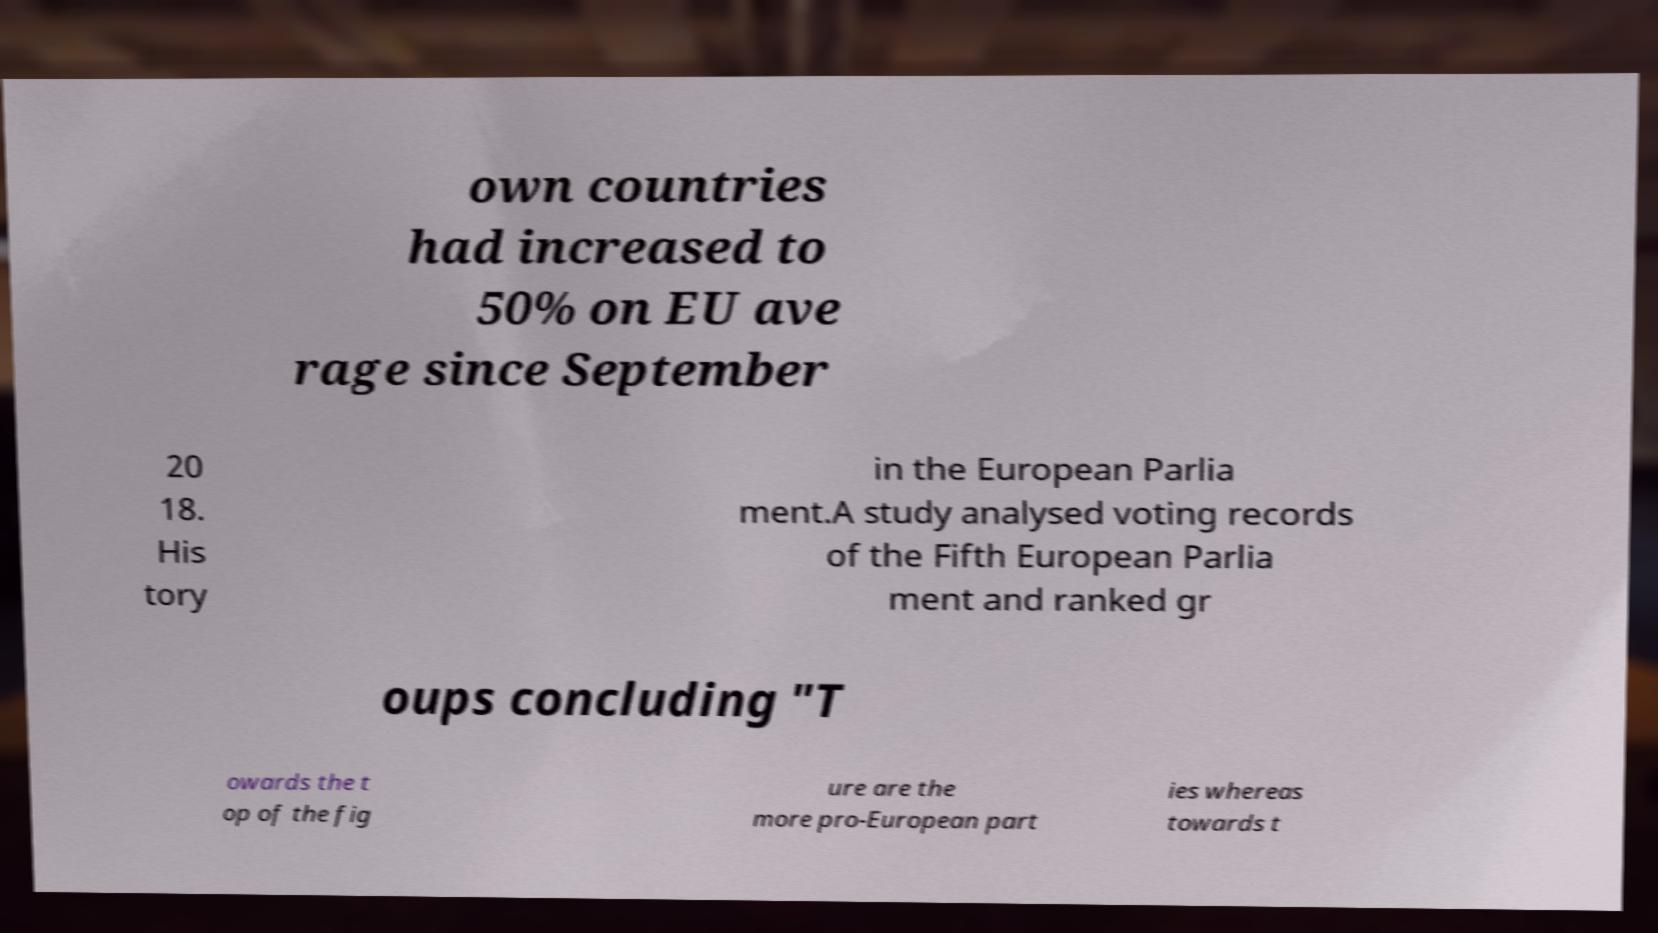Please identify and transcribe the text found in this image. own countries had increased to 50% on EU ave rage since September 20 18. His tory in the European Parlia ment.A study analysed voting records of the Fifth European Parlia ment and ranked gr oups concluding "T owards the t op of the fig ure are the more pro-European part ies whereas towards t 